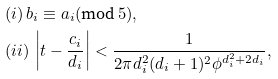<formula> <loc_0><loc_0><loc_500><loc_500>& ( i ) \, b _ { i } \equiv a _ { i } ( \text {mod} \, 5 ) , \\ & ( i i ) \, \left | t - \frac { c _ { i } } { d _ { i } } \right | < \frac { 1 } { 2 \pi d _ { i } ^ { 2 } ( d _ { i } + 1 ) ^ { 2 } \phi ^ { d _ { i } ^ { 2 } + 2 d _ { i } } } ,</formula> 